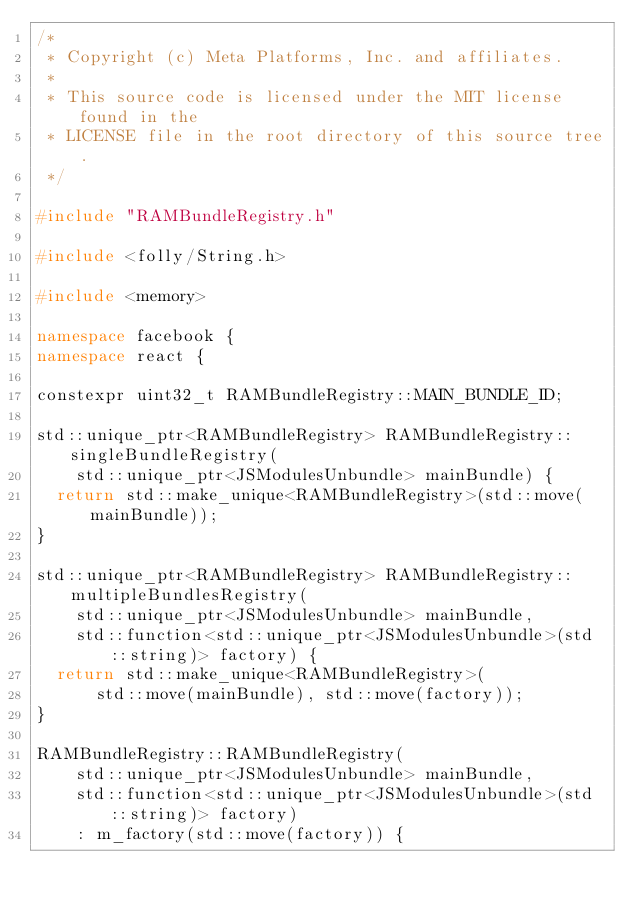<code> <loc_0><loc_0><loc_500><loc_500><_C++_>/*
 * Copyright (c) Meta Platforms, Inc. and affiliates.
 *
 * This source code is licensed under the MIT license found in the
 * LICENSE file in the root directory of this source tree.
 */

#include "RAMBundleRegistry.h"

#include <folly/String.h>

#include <memory>

namespace facebook {
namespace react {

constexpr uint32_t RAMBundleRegistry::MAIN_BUNDLE_ID;

std::unique_ptr<RAMBundleRegistry> RAMBundleRegistry::singleBundleRegistry(
    std::unique_ptr<JSModulesUnbundle> mainBundle) {
  return std::make_unique<RAMBundleRegistry>(std::move(mainBundle));
}

std::unique_ptr<RAMBundleRegistry> RAMBundleRegistry::multipleBundlesRegistry(
    std::unique_ptr<JSModulesUnbundle> mainBundle,
    std::function<std::unique_ptr<JSModulesUnbundle>(std::string)> factory) {
  return std::make_unique<RAMBundleRegistry>(
      std::move(mainBundle), std::move(factory));
}

RAMBundleRegistry::RAMBundleRegistry(
    std::unique_ptr<JSModulesUnbundle> mainBundle,
    std::function<std::unique_ptr<JSModulesUnbundle>(std::string)> factory)
    : m_factory(std::move(factory)) {</code> 